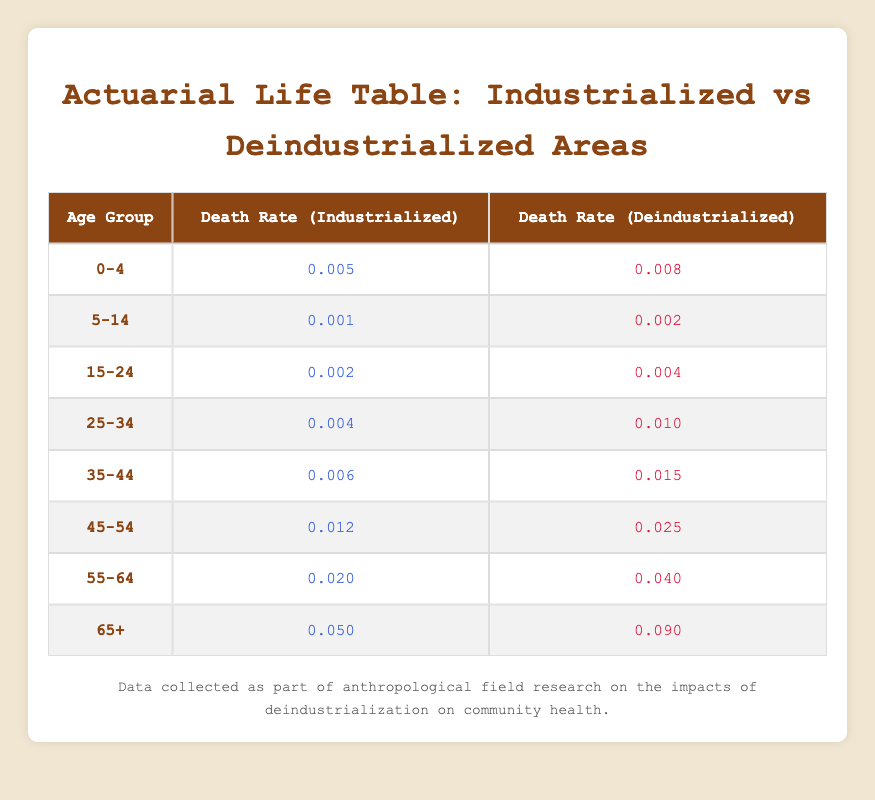What is the death rate for the age group 0-4 in industrialized areas? The table shows the death rate for the age group 0-4 in industrialized areas is listed under that specific row, which reads 0.005.
Answer: 0.005 What is the death rate for the age group 25-34 in deindustrialized areas? The table indicates that for the age group 25-34, the death rate in deindustrialized areas is found in that row, which is 0.010.
Answer: 0.010 Is the death rate for all age groups higher in deindustrialized areas compared to industrialized areas? By comparing each row in the table, we can see that all the death rates for the deindustrialized areas are greater than those for the industrialized areas for every age group.
Answer: Yes What is the difference in death rates between the age groups 45-54 in industrialized and deindustrialized areas? To find the difference, subtract the industrialized rate (0.012) from the deindustrialized rate (0.025): 0.025 - 0.012 = 0.013.
Answer: 0.013 How much higher is the death rate for the age group 65+ in deindustrialized areas compared to industrialized areas? The death rate for age group 65+ in deindustrialized areas is 0.090, and in industrialized areas it is 0.050. The increase is calculated by subtracting the two rates: 0.090 - 0.050 = 0.040.
Answer: 0.040 Does the age group 55-64 have a death rate lower than 0.030 in industrialized areas? The table shows that the death rate for the age group 55-64 in industrialized areas is 0.020, which is indeed lower than 0.030.
Answer: Yes What is the average death rate for the age groups 0-4 and 5-14 in deindustrialized areas? First, extract the death rates: 0.008 for age group 0-4 and 0.002 for age group 5-14. Then, calculate the average: (0.008 + 0.002) / 2 = 0.005.
Answer: 0.005 Which age group has the highest death rate in deindustrialized areas? By examining the death rates from the table for deindustrialized areas, the age group 65+ has the highest value of 0.090.
Answer: 65+ What is the total death rate for all age groups in industrialized areas? To calculate the total death rate, sum all the death rates in the industrialized areas: 0.005 + 0.001 + 0.002 + 0.004 + 0.006 + 0.012 + 0.020 + 0.050 = 0.100.
Answer: 0.100 Is the death rate for the age group 15-24 in deindustrialized areas the same as that in industrialized areas? Comparing the rates from the table, the death rate for age group 15-24 in deindustrialized areas is 0.004, while in industrialized areas it is 0.002, indicating they are not the same.
Answer: No 